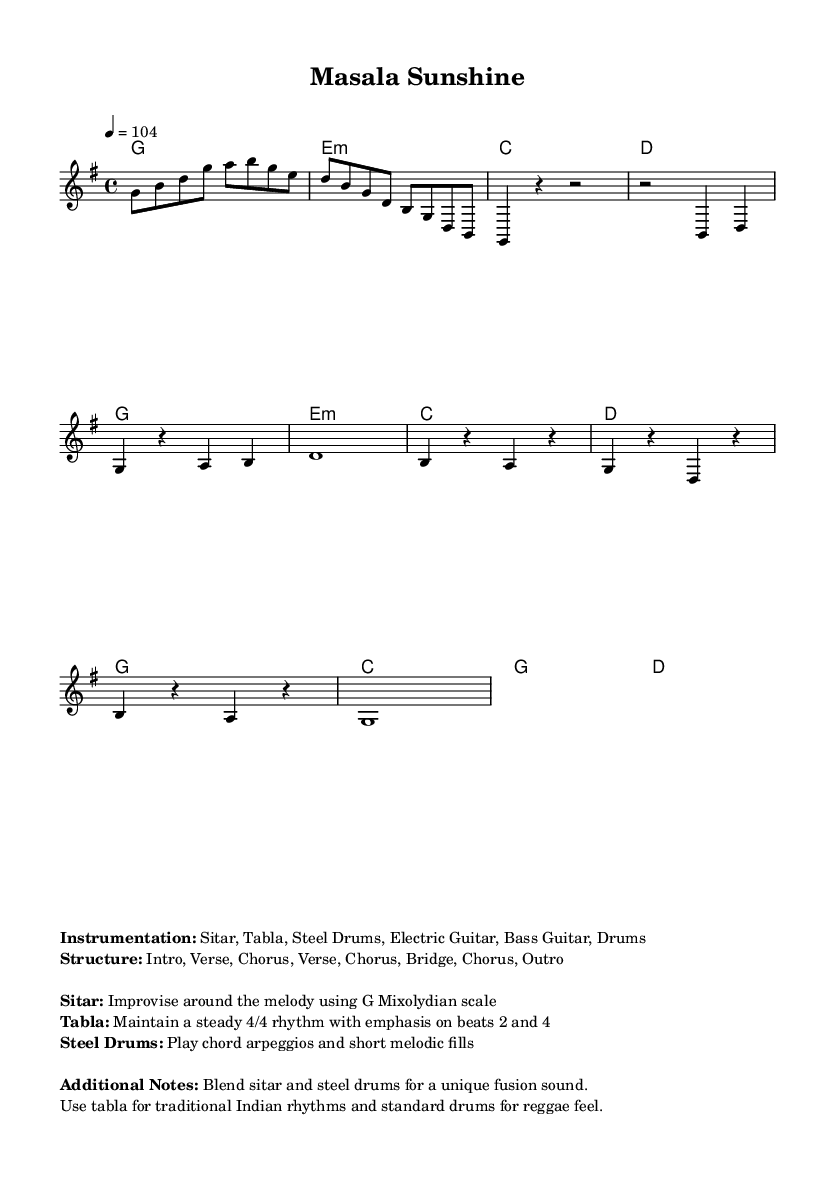What is the key signature of this music? The key signature is G major, indicated by one sharp (F#) in the key signature line at the beginning of the music.
Answer: G major What is the time signature of the piece? The time signature is shown as 4/4, meaning there are four beats in each measure and the quarter note receives one beat.
Answer: 4/4 What is the tempo marking of the composition? The tempo marking indicates that the piece should be played at a speed of 104 beats per minute, noted above the staff.
Answer: 104 How many sections does the music have? The structure section mentions multiple parts, specifically listing an Intro, two Verses, one Bridge, and multiple Choruses, totaling six distinct sections.
Answer: Six What instruments are used in this piece? The instrumentation section lists Sitar, Tabla, Steel Drums, Electric Guitar, Bass Guitar, and Drums, which are all necessary for the arrangement of this reggae fusion.
Answer: Sitar, Tabla, Steel Drums, Electric Guitar, Bass Guitar, Drums What rhythm does the Tabla maintain? The section notes that the Tabla's role is to maintain a steady 4/4 rhythm, specifically emphasizing beats 2 and 4, creating a traditional feel.
Answer: 4/4 rhythm on beats 2 and 4 What is unique about the fusion in this piece? The notes highlight that the piece blends Indian classical instruments, like the sitar and tabla, with Caribbean steel drums, which creates a distinctive reggae fusion sound.
Answer: Blend sitar and steel drums 